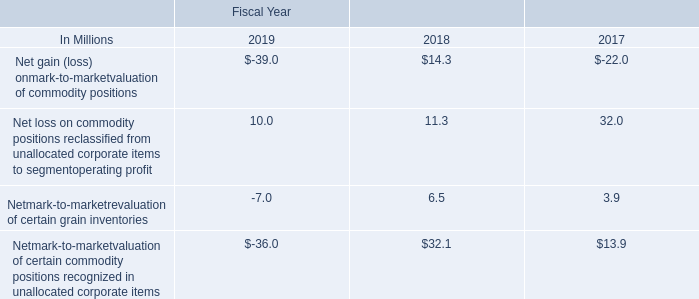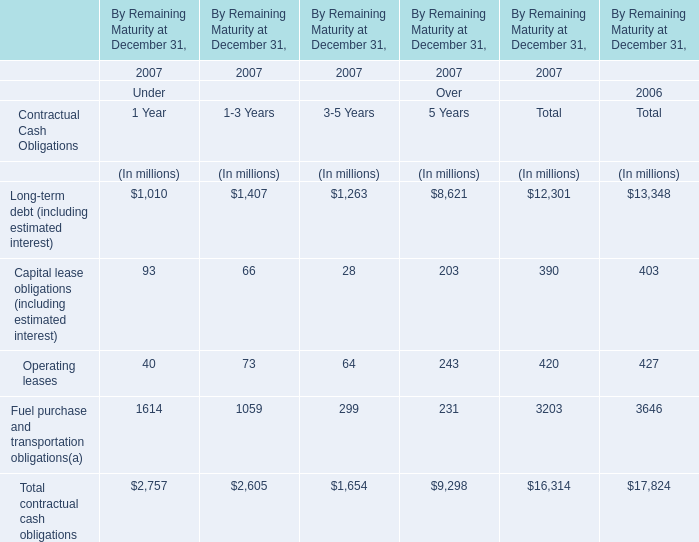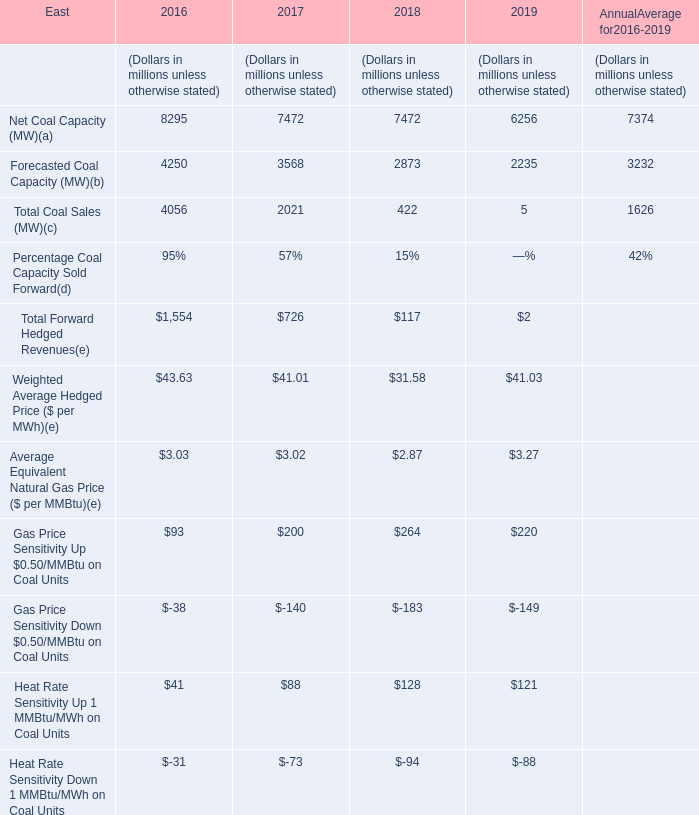what portion of the net notional value of commodity derivatives is related to energy inputs? 
Computations: (69.6 / 242.9)
Answer: 0.28654. 